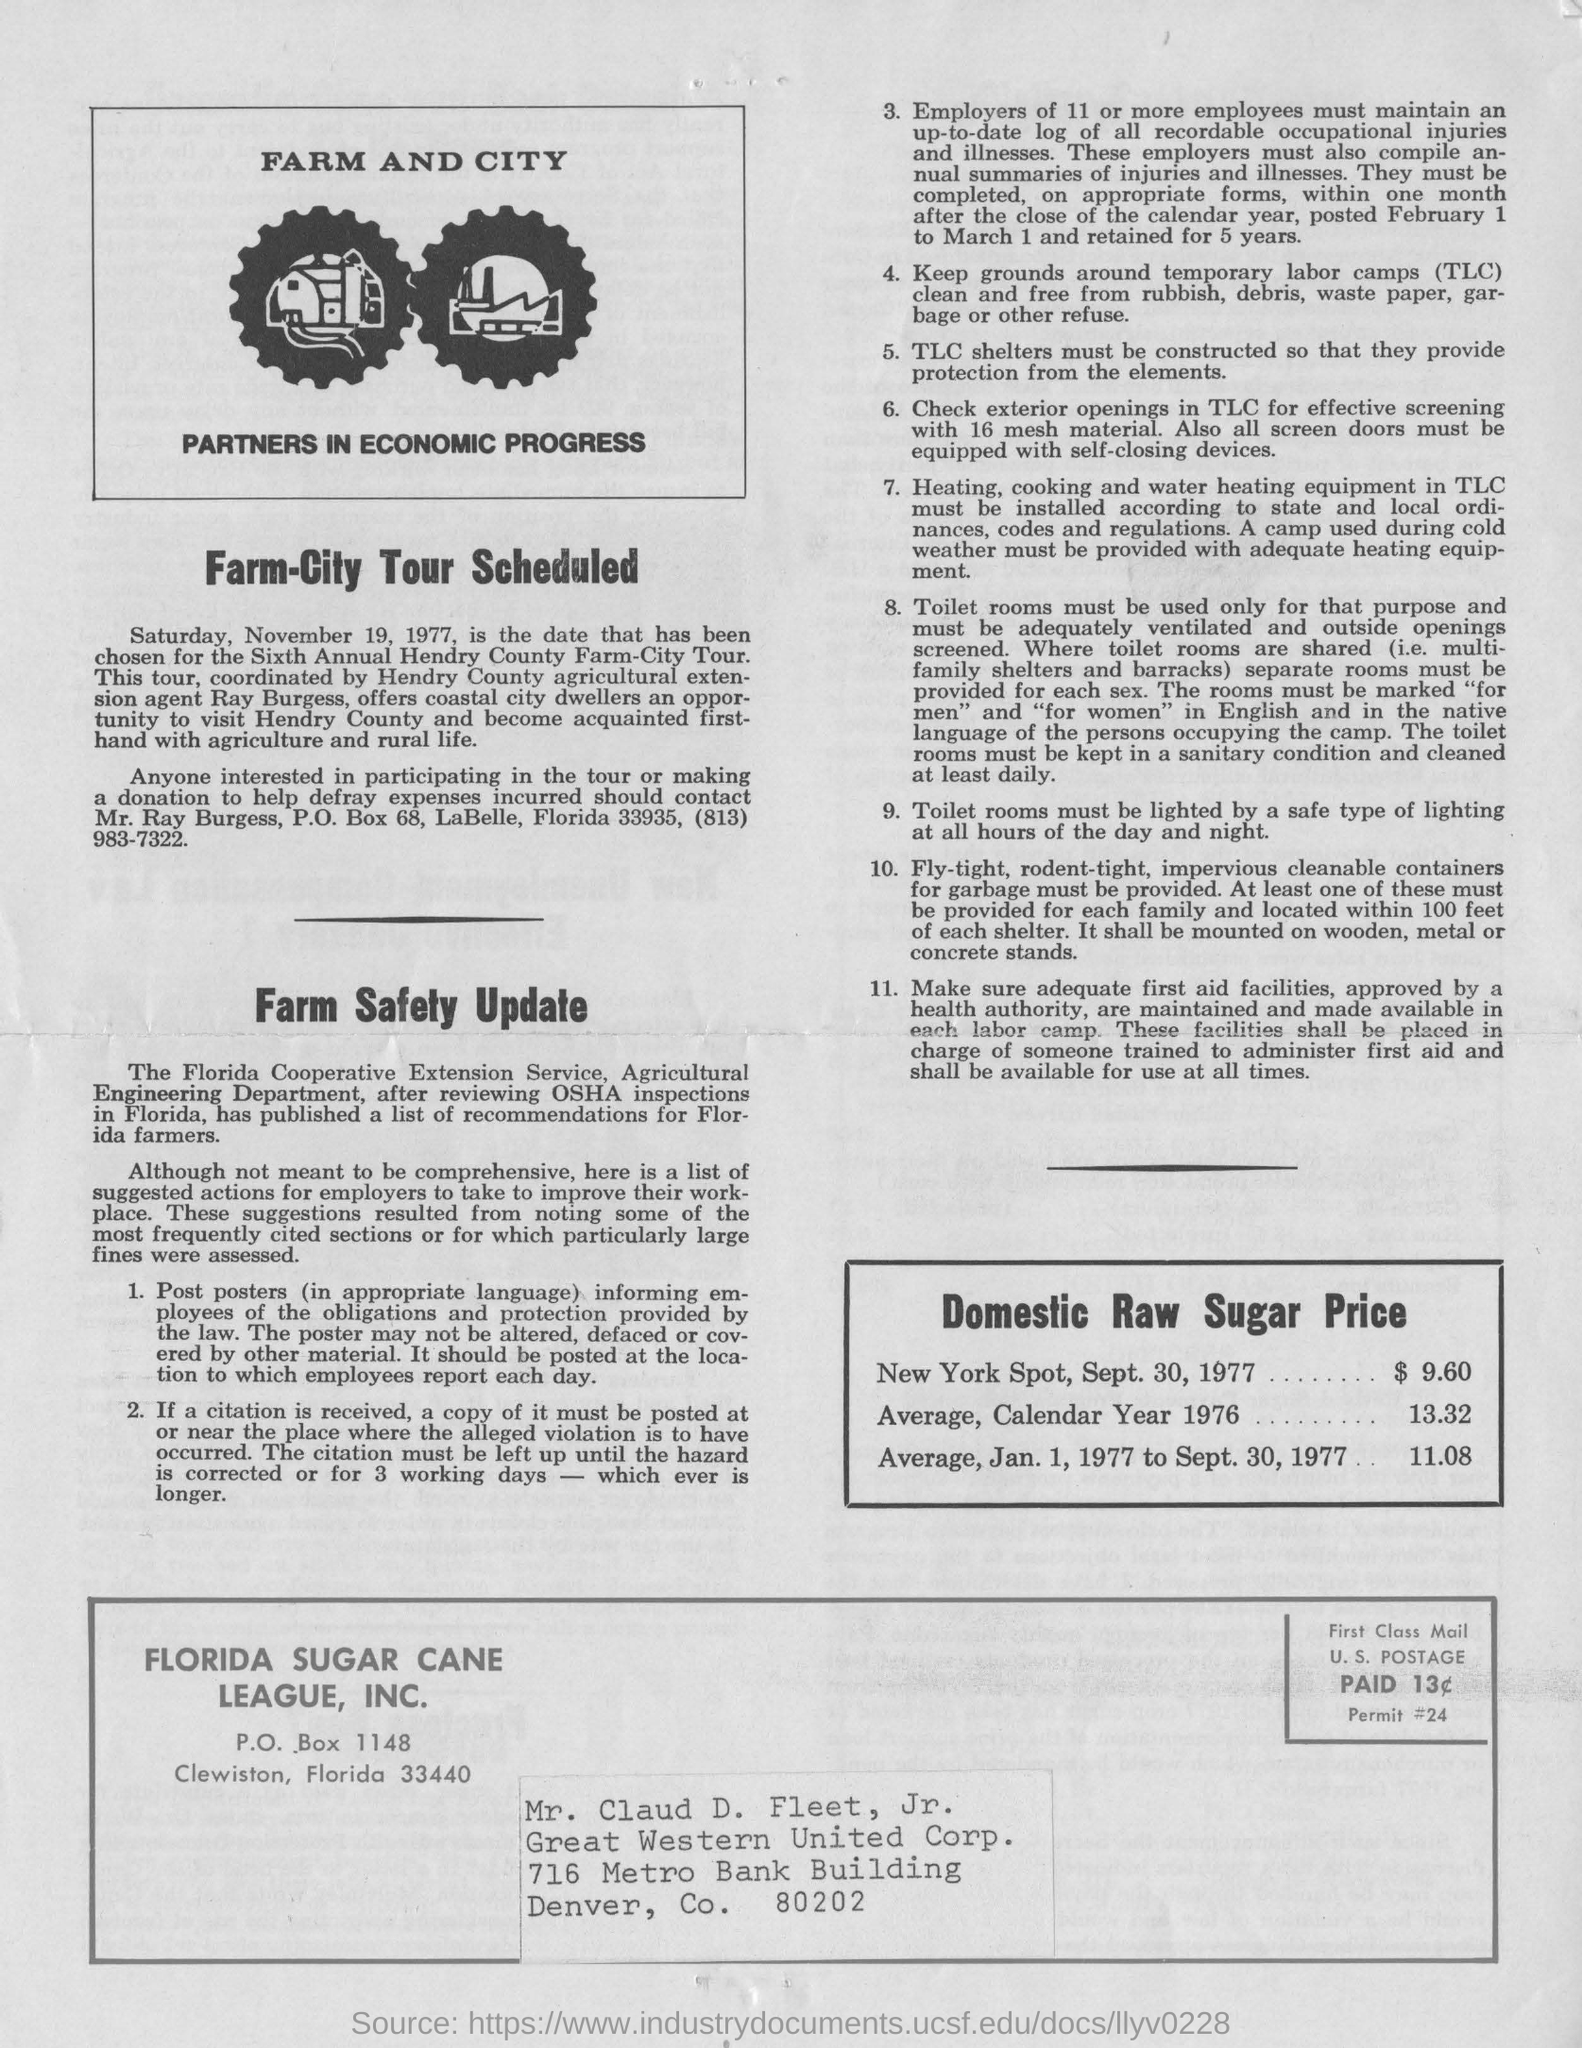Identify some key points in this picture. TLC stands for temporary labor camps, which are facilities designed to provide temporary housing and support for workers engaged in manual labor or other physically demanding tasks. The sixth annual Henry County Farm City Tour will take place on Saturday, November 19, 1977. On September 30th, 1977, the domestic Raw sugar price at the New York spot was $9.60. The agricultural extension agent, Ray Burgess, provides coastal city dwellers with the opportunity to visit Hendry County. The contact address for participation in the tour or making a donation to defray expenses is Mr. Ray Burgess, P.O. Box 68, LaBelle, Florida 33935, (813) 983-7322. 